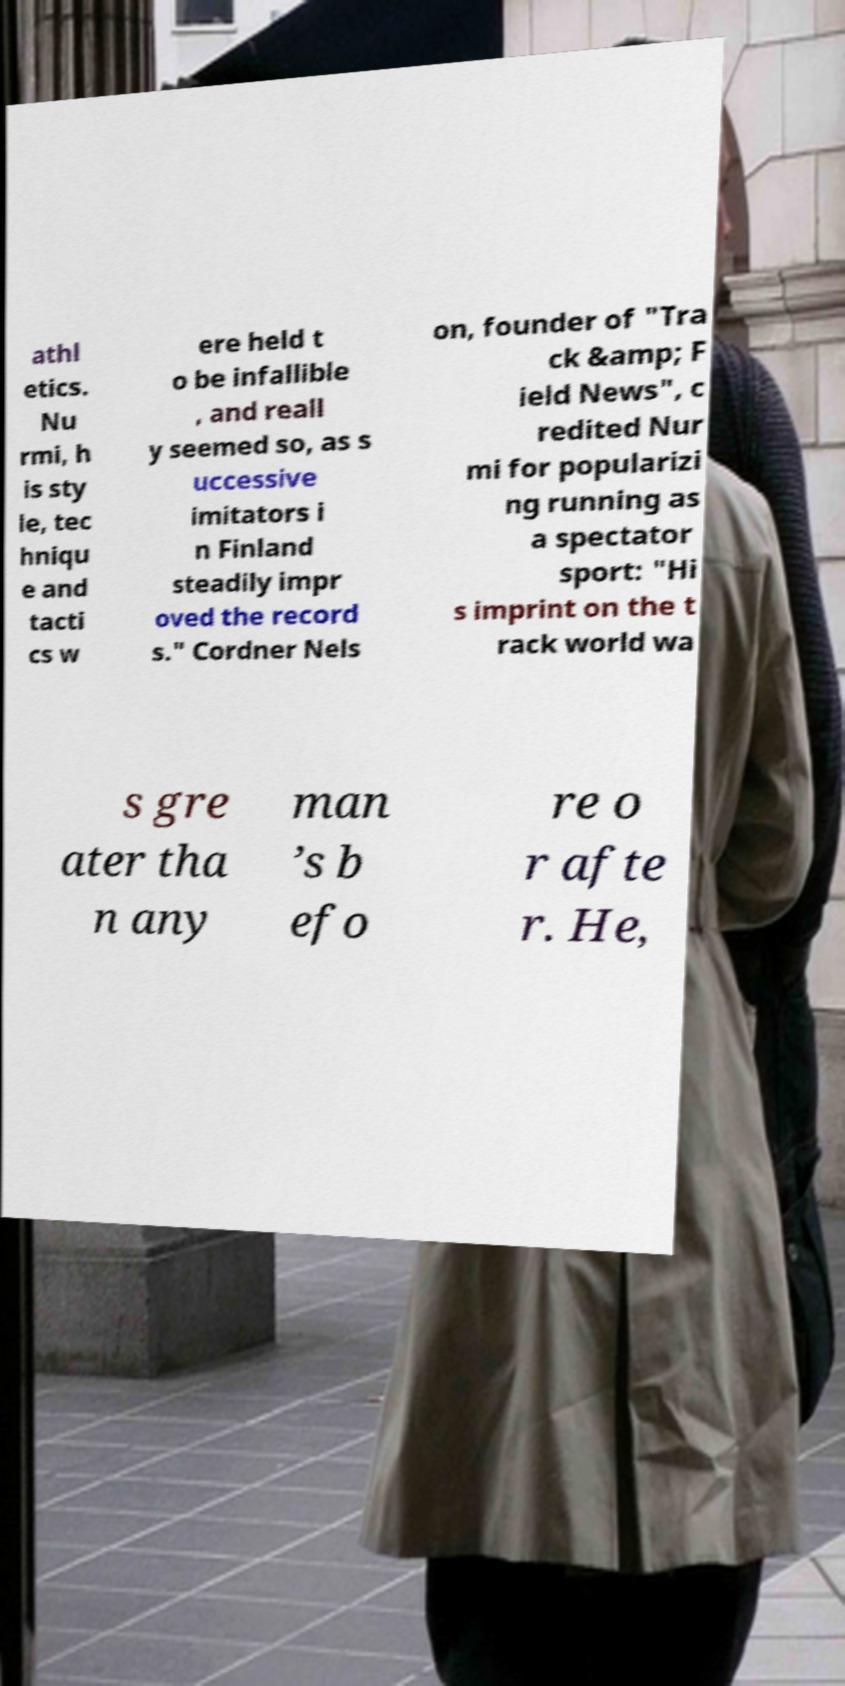For documentation purposes, I need the text within this image transcribed. Could you provide that? athl etics. Nu rmi, h is sty le, tec hniqu e and tacti cs w ere held t o be infallible , and reall y seemed so, as s uccessive imitators i n Finland steadily impr oved the record s." Cordner Nels on, founder of "Tra ck &amp; F ield News", c redited Nur mi for popularizi ng running as a spectator sport: "Hi s imprint on the t rack world wa s gre ater tha n any man ’s b efo re o r afte r. He, 